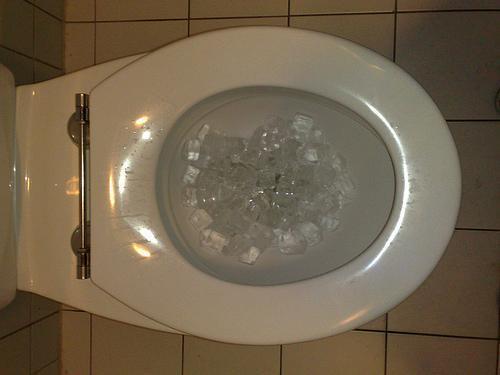How many toilets are there?
Give a very brief answer. 1. 